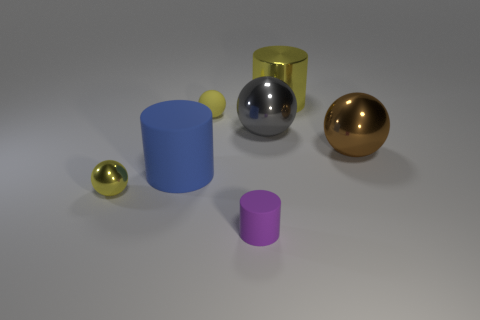Subtract 1 spheres. How many spheres are left? 3 Add 1 large blue metallic cubes. How many objects exist? 8 Subtract all balls. How many objects are left? 3 Add 2 large red things. How many large red things exist? 2 Subtract 0 cyan balls. How many objects are left? 7 Subtract all purple cubes. Subtract all tiny cylinders. How many objects are left? 6 Add 3 tiny cylinders. How many tiny cylinders are left? 4 